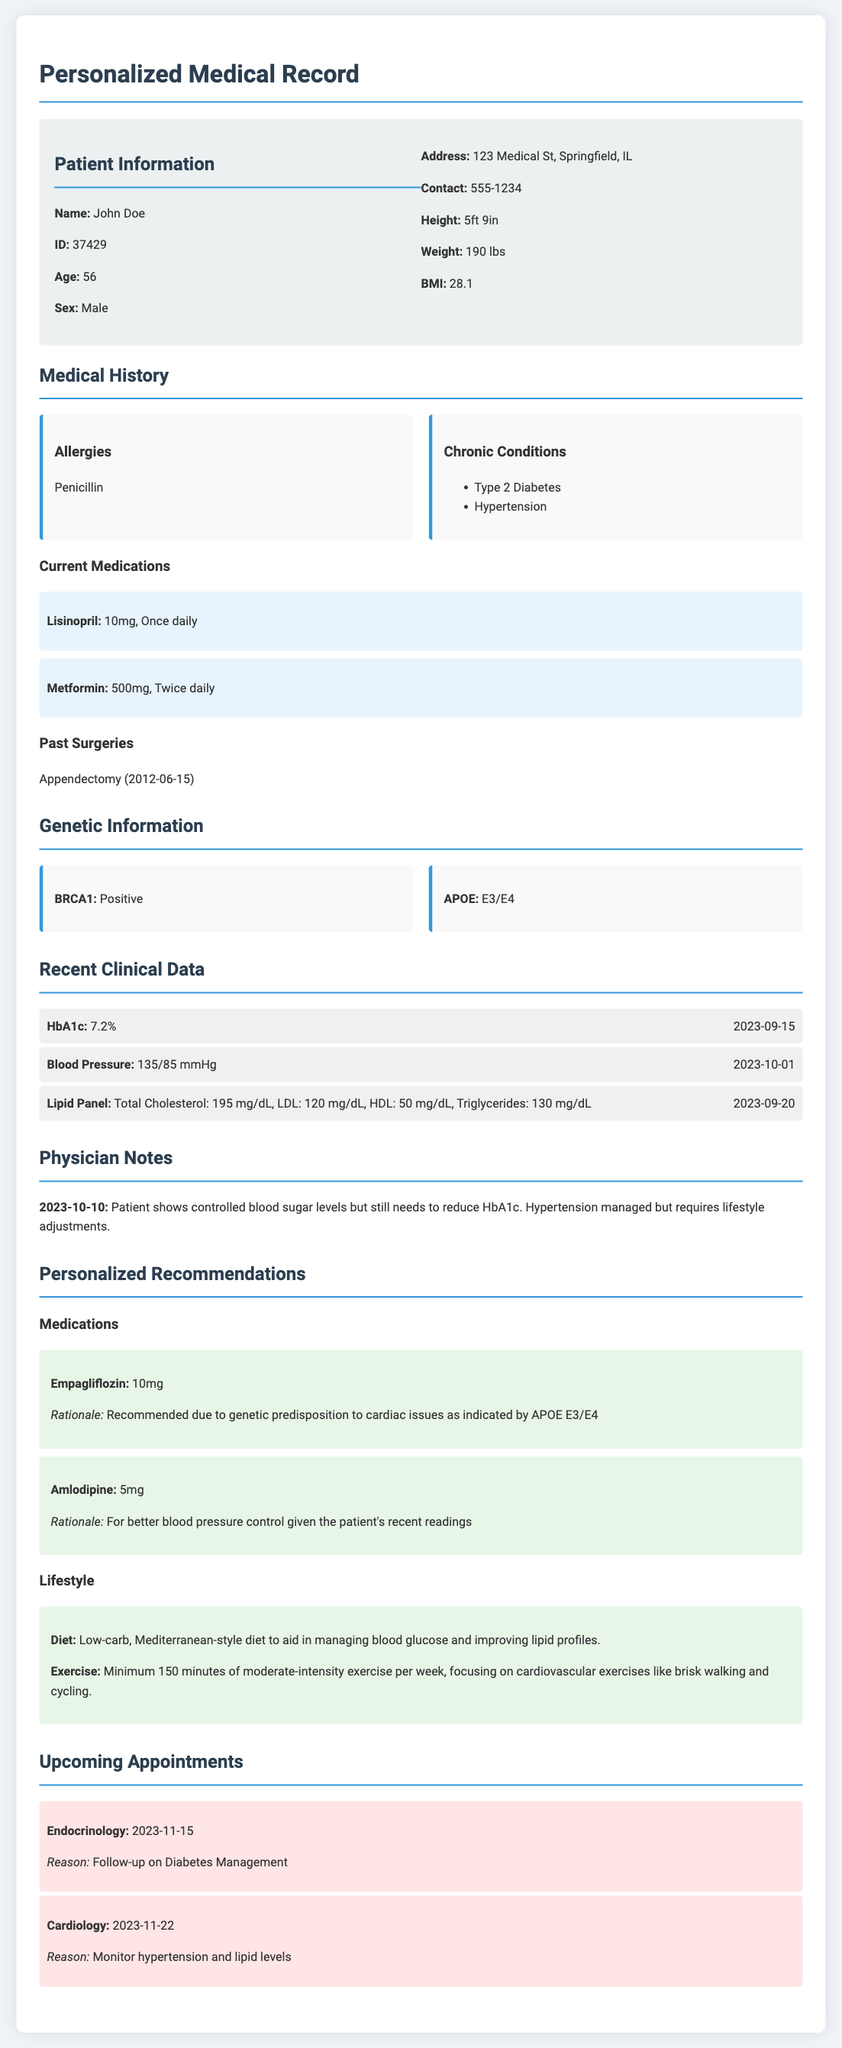What is the patient's name? The patient is identified at the top of the document under the Patient Information section.
Answer: John Doe What medications is the patient currently taking? The current medications are listed under the Medical History section with dosages indicated.
Answer: Lisinopril, Metformin What is the patient's age? The age is provided in the Patient Information section.
Answer: 56 What is the reason for the upcoming Endocrinology appointment? The reason is specified in the Upcoming Appointments section.
Answer: Follow-up on Diabetes Management What is the patient's BMI? The BMI is listed in the Patient Information section alongside other vital statistics.
Answer: 28.1 What lifestyle change is recommended for the patient's diet? The dietary recommendation is mentioned in the Personalized Recommendations section under Lifestyle.
Answer: Low-carb, Mediterranean-style diet What genetic predisposition is indicated in the document? The genetic information section lists specific genetic markers relevant to the patient's health.
Answer: APOE E3/E4 What was the most recent HbA1c result recorded? The result is found in the Recent Clinical Data section with its corresponding date.
Answer: 7.2% What chronic conditions does the patient have? Chronic conditions are explicitly listed in the Medical History section.
Answer: Type 2 Diabetes, Hypertension 